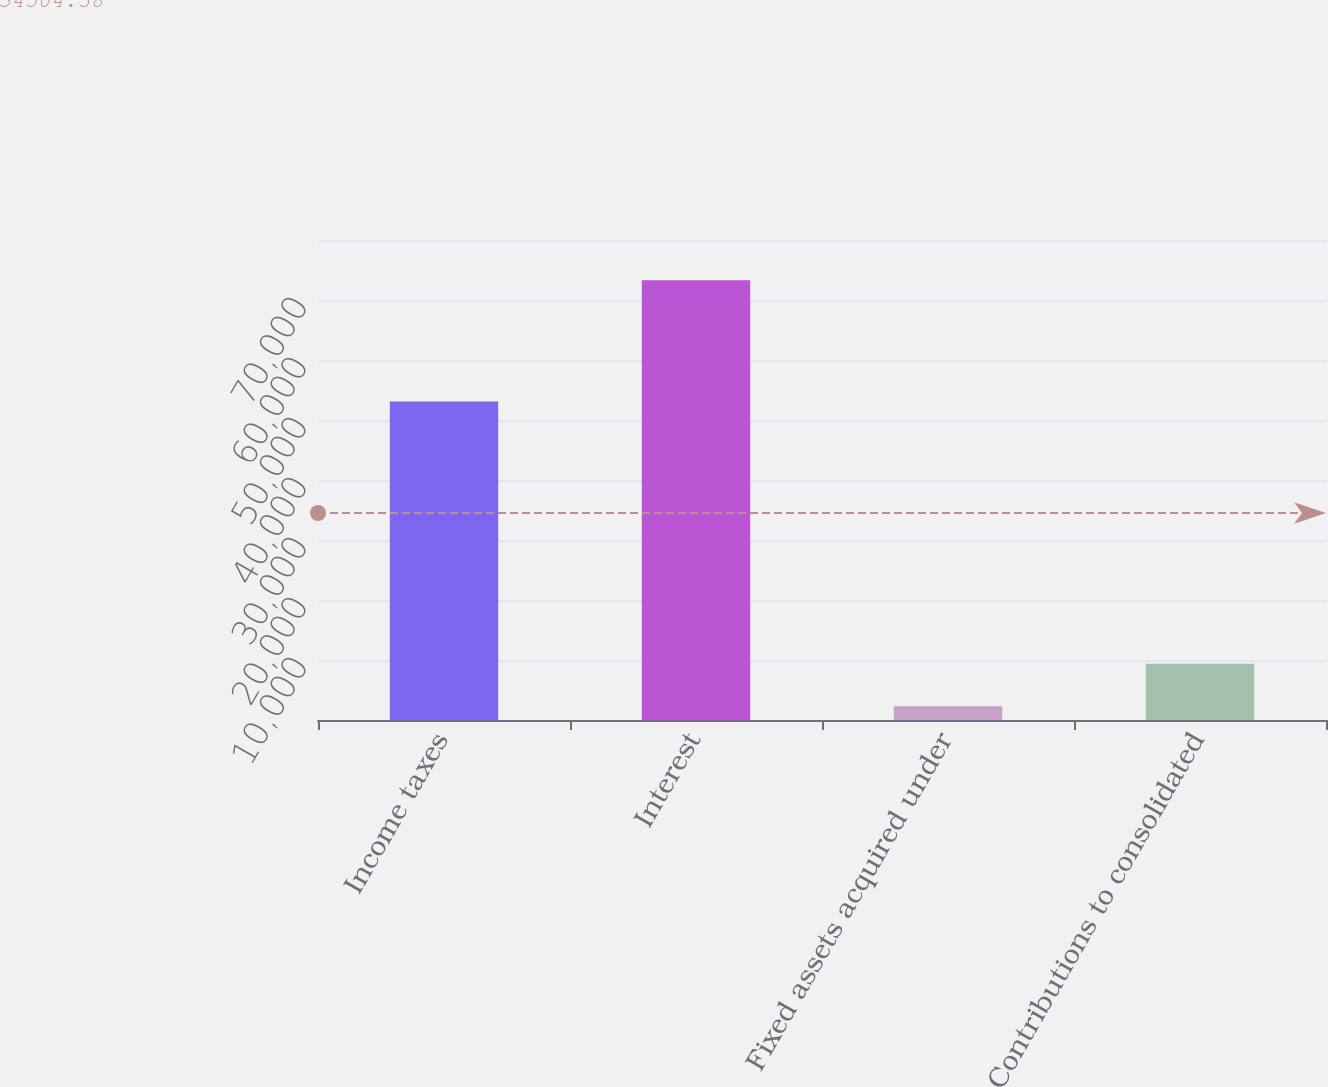Convert chart to OTSL. <chart><loc_0><loc_0><loc_500><loc_500><bar_chart><fcel>Income taxes<fcel>Interest<fcel>Fixed assets acquired under<fcel>Contributions to consolidated<nl><fcel>53074<fcel>73278<fcel>2283<fcel>9382.5<nl></chart> 